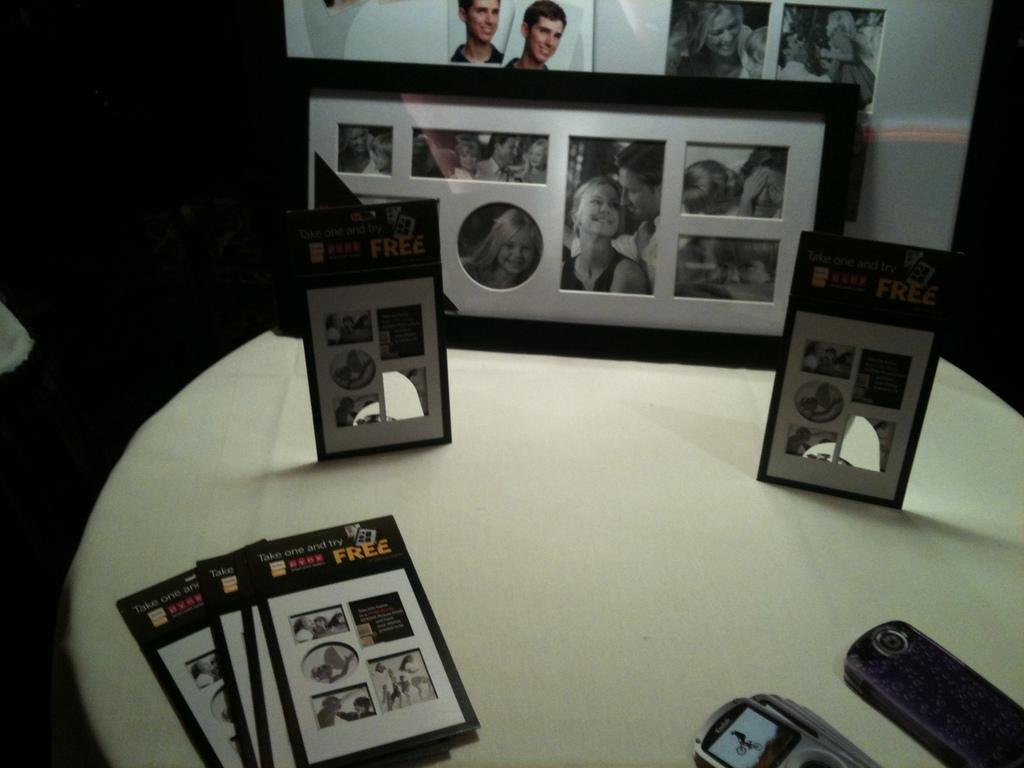<image>
Share a concise interpretation of the image provided. Pamphlets that say "Take one and try" are on a table with pictures and cameras. 